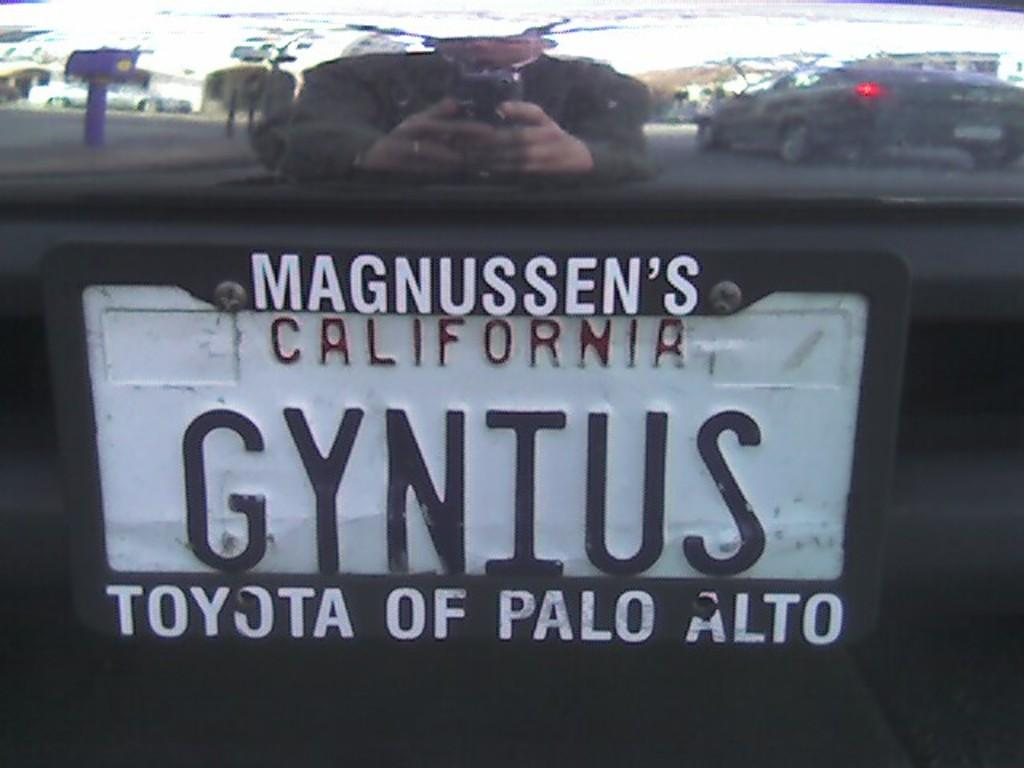<image>
Create a compact narrative representing the image presented. A license plate has MAGNUSSEN'S CALIFORNIA GYNIUS TOYOTA OF PALO ALTO on it. 